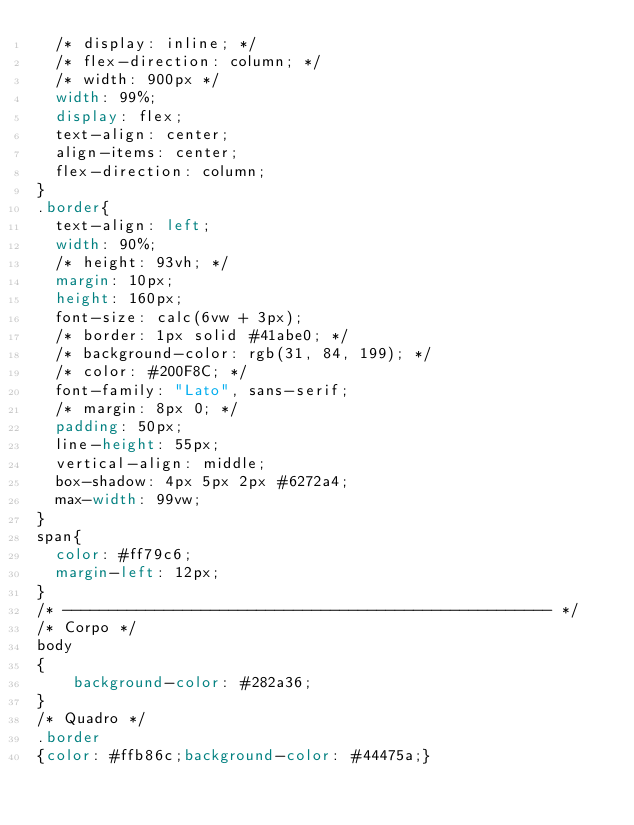<code> <loc_0><loc_0><loc_500><loc_500><_CSS_>  /* display: inline; */
  /* flex-direction: column; */
  /* width: 900px */
  width: 99%;
  display: flex;
  text-align: center;
  align-items: center;
  flex-direction: column;
}
.border{
  text-align: left;
  width: 90%;
  /* height: 93vh; */
  margin: 10px;
  height: 160px;
  font-size: calc(6vw + 3px);
  /* border: 1px solid #41abe0; */
  /* background-color: rgb(31, 84, 199); */
  /* color: #200F8C; */
  font-family: "Lato", sans-serif;
  /* margin: 8px 0; */
  padding: 50px;
  line-height: 55px;
  vertical-align: middle;
  box-shadow: 4px 5px 2px #6272a4;
  max-width: 99vw;
}
span{
  color: #ff79c6;
  margin-left: 12px;
}
/* ----------------------------------------------------- */
/* Corpo */
body
{
    background-color: #282a36;
}
/* Quadro */
.border
{color: #ffb86c;background-color: #44475a;}

</code> 